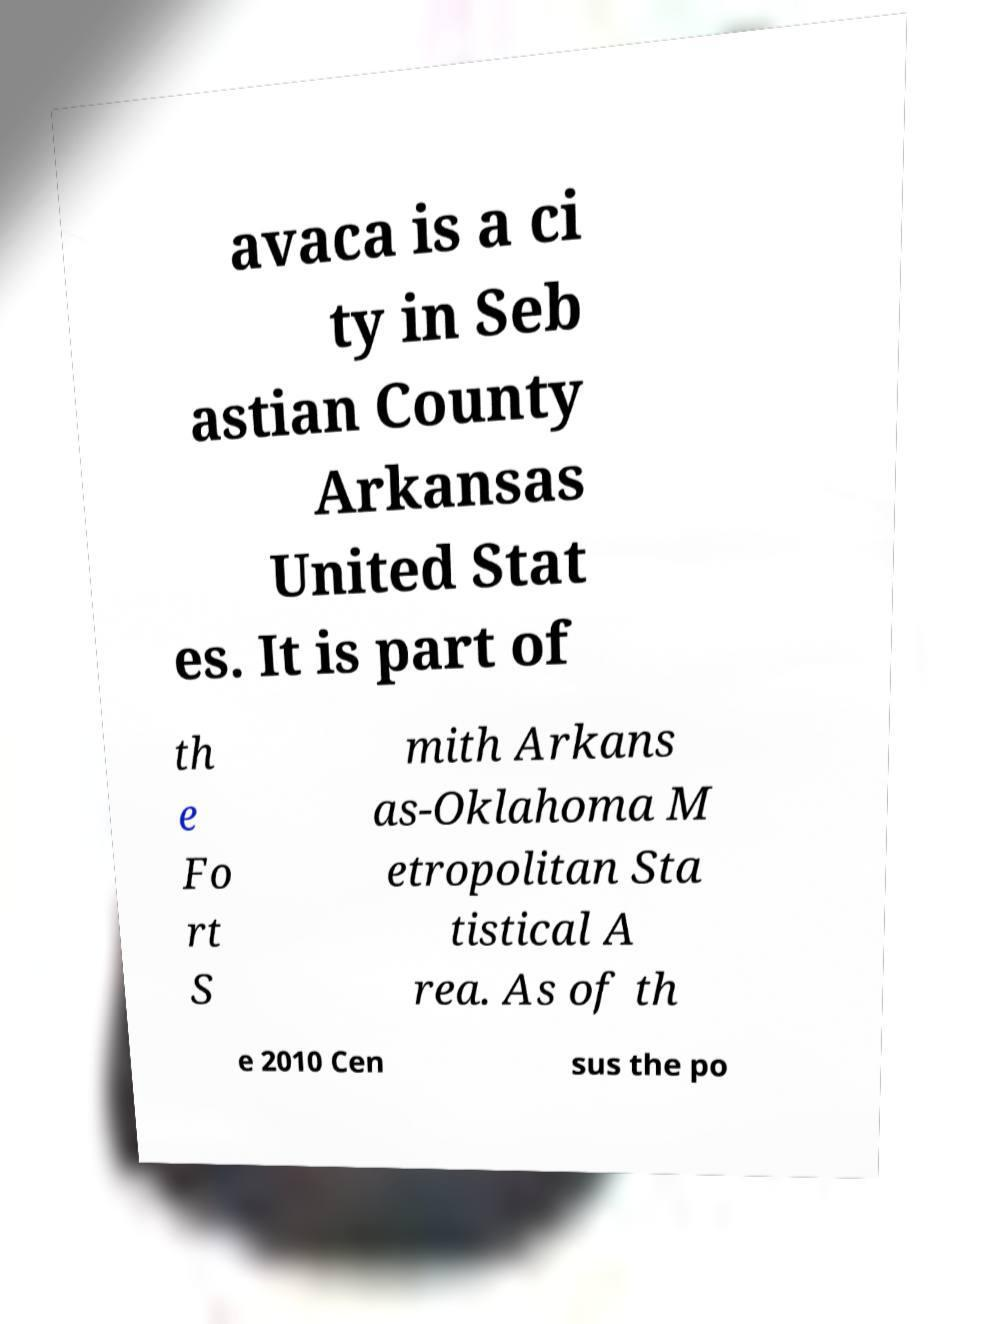Can you accurately transcribe the text from the provided image for me? avaca is a ci ty in Seb astian County Arkansas United Stat es. It is part of th e Fo rt S mith Arkans as-Oklahoma M etropolitan Sta tistical A rea. As of th e 2010 Cen sus the po 